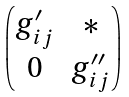<formula> <loc_0><loc_0><loc_500><loc_500>\begin{pmatrix} g ^ { \prime } _ { i j } & * \\ 0 & g ^ { \prime \prime } _ { i j } \end{pmatrix}</formula> 